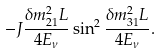Convert formula to latex. <formula><loc_0><loc_0><loc_500><loc_500>- J \frac { \delta m ^ { 2 } _ { 2 1 } L } { 4 E _ { \nu } } \sin ^ { 2 } \frac { \delta m ^ { 2 } _ { 3 1 } L } { 4 E _ { \nu } } .</formula> 